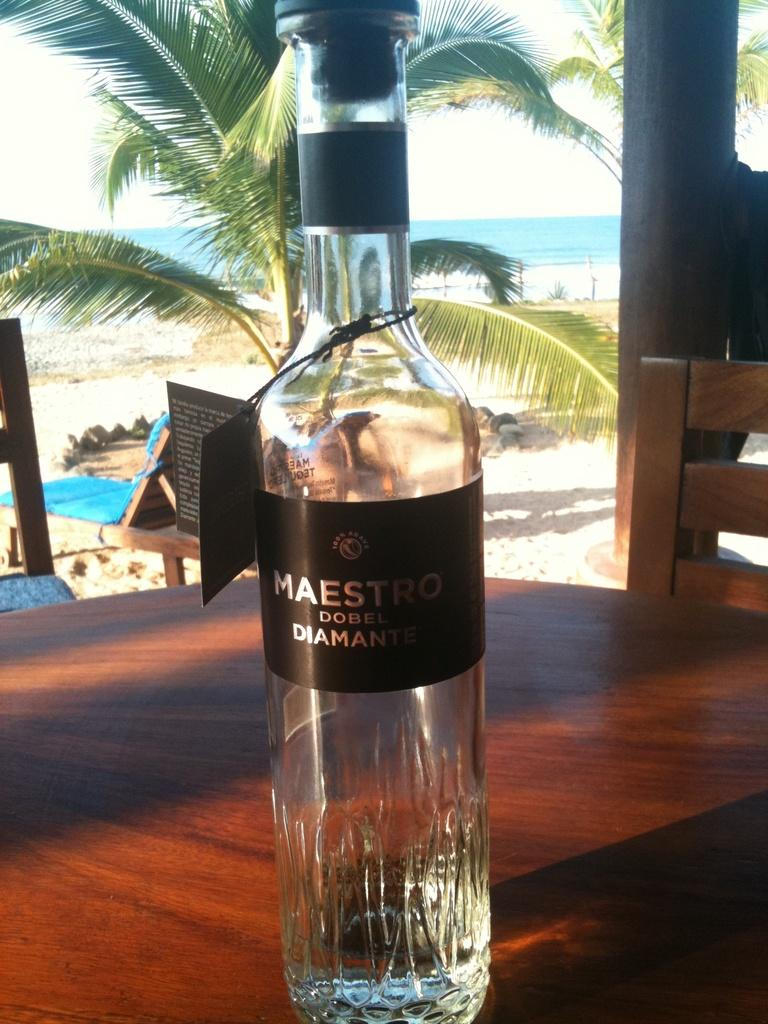What object is visible in the image that is made of glass? There is a glass bottle in the image. Where is the glass bottle located? The glass bottle is placed on a table. What can be seen in the background of the image? There is a tree and a beach in the background of the image. What is the reason for the glass bottle being placed on a seat in the image? There is no seat present in the image, and the glass bottle is placed on a table, not a seat. 